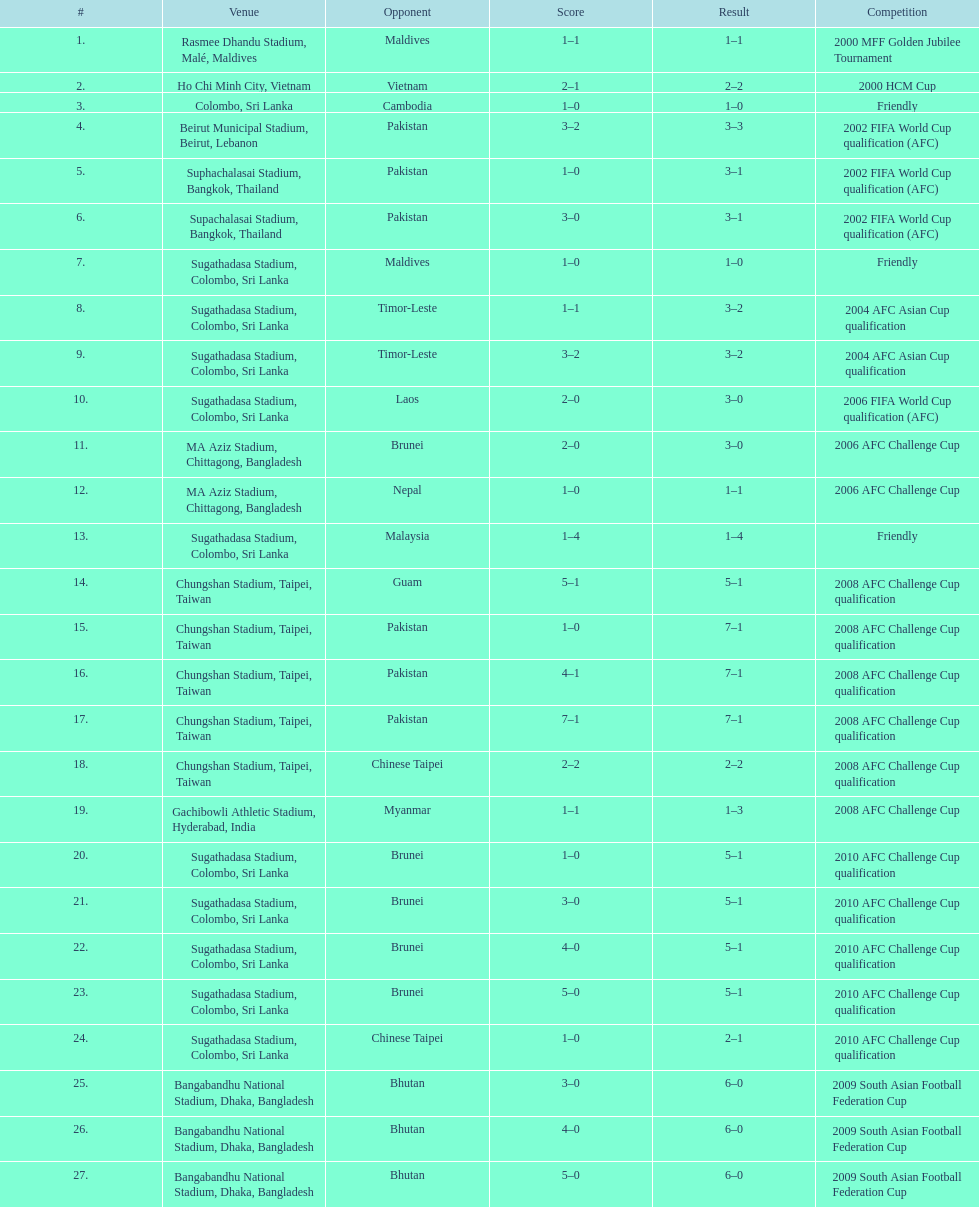How often was laos the opposing team? 1. 